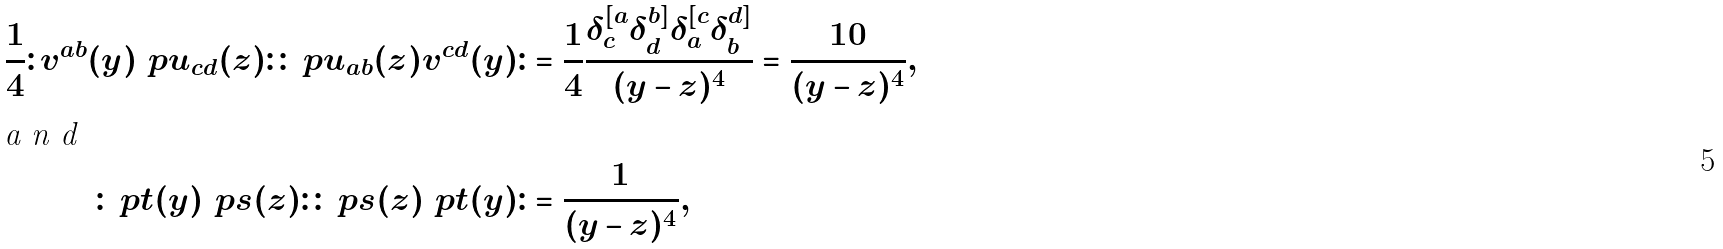Convert formula to latex. <formula><loc_0><loc_0><loc_500><loc_500>\frac { 1 } { 4 } \colon v ^ { a b } ( y ) \ p u _ { c d } ( z ) \colon \colon \ p u _ { a b } ( z ) v ^ { c d } ( y ) \colon & = \frac { 1 } { 4 } \frac { \delta ^ { [ a } _ { c } \delta ^ { b ] } _ { d } \delta ^ { [ c } _ { a } \delta ^ { d ] } _ { b } } { ( y - z ) ^ { 4 } } = \frac { 1 0 } { ( y - z ) ^ { 4 } } , \\ \intertext { a n d } \colon \ p t ( y ) \ p s ( z ) \colon \colon \ p s ( z ) \ p t ( y ) \colon & = \frac { 1 } { ( y - z ) ^ { 4 } } ,</formula> 